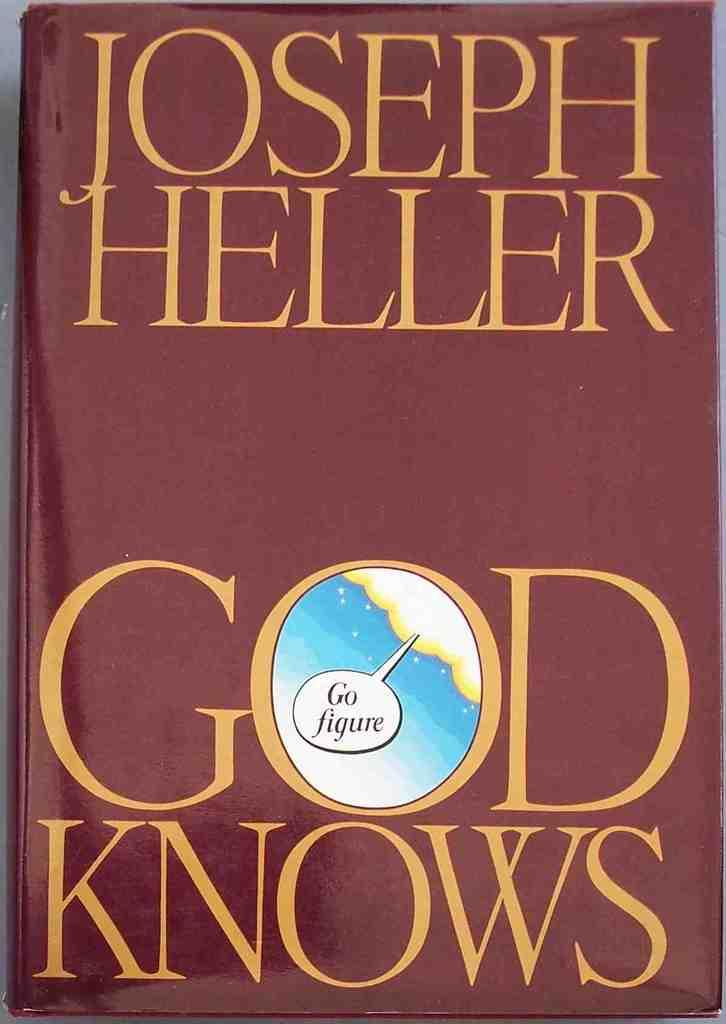<image>
Relay a brief, clear account of the picture shown. A fictional tale implying God Knows about everything. 